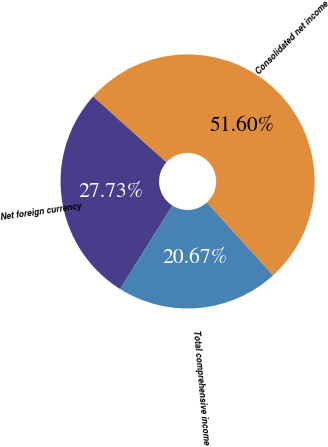Convert chart. <chart><loc_0><loc_0><loc_500><loc_500><pie_chart><fcel>Consolidated net income<fcel>Net foreign currency<fcel>Total comprehensive income<nl><fcel>51.6%<fcel>27.73%<fcel>20.67%<nl></chart> 